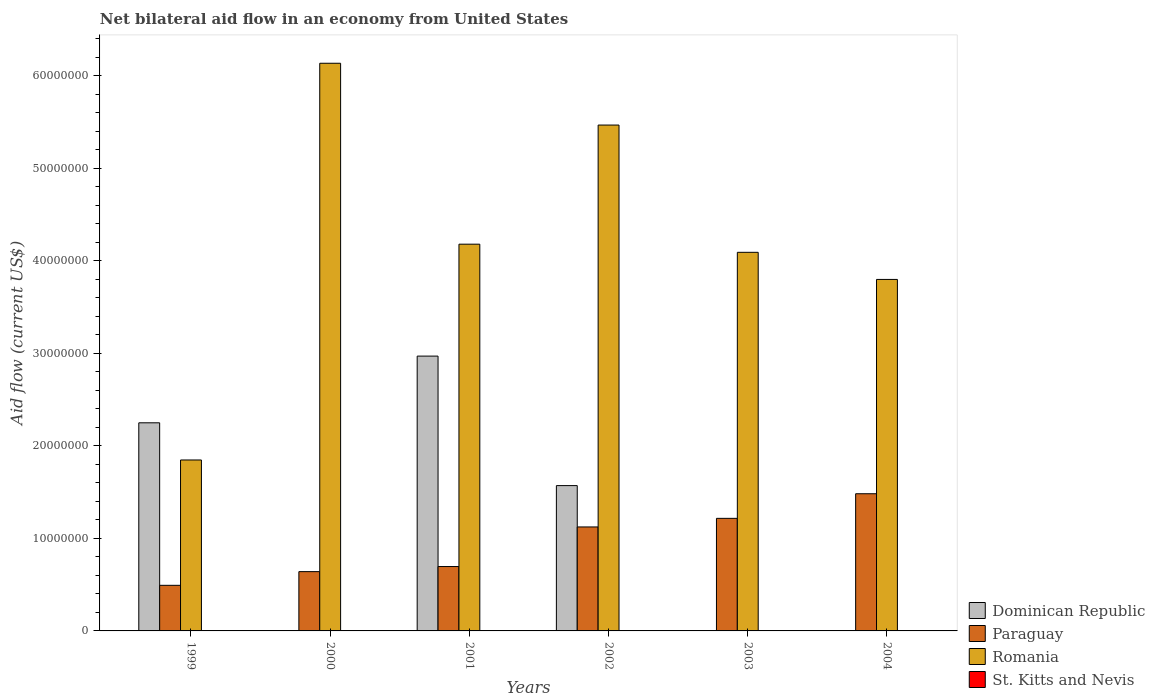How many different coloured bars are there?
Provide a short and direct response. 3. How many groups of bars are there?
Make the answer very short. 6. Are the number of bars per tick equal to the number of legend labels?
Ensure brevity in your answer.  No. What is the net bilateral aid flow in Romania in 2001?
Provide a short and direct response. 4.18e+07. Across all years, what is the maximum net bilateral aid flow in Paraguay?
Keep it short and to the point. 1.48e+07. Across all years, what is the minimum net bilateral aid flow in Romania?
Your answer should be very brief. 1.85e+07. In which year was the net bilateral aid flow in Romania maximum?
Your response must be concise. 2000. What is the total net bilateral aid flow in Dominican Republic in the graph?
Make the answer very short. 6.79e+07. What is the difference between the net bilateral aid flow in Romania in 1999 and that in 2001?
Your answer should be compact. -2.33e+07. What is the difference between the net bilateral aid flow in Paraguay in 2003 and the net bilateral aid flow in St. Kitts and Nevis in 2002?
Provide a short and direct response. 1.22e+07. What is the average net bilateral aid flow in Romania per year?
Your response must be concise. 4.25e+07. In the year 1999, what is the difference between the net bilateral aid flow in Paraguay and net bilateral aid flow in Romania?
Give a very brief answer. -1.36e+07. What is the ratio of the net bilateral aid flow in Paraguay in 2002 to that in 2003?
Make the answer very short. 0.92. Is the net bilateral aid flow in Romania in 2001 less than that in 2003?
Provide a succinct answer. No. Is the difference between the net bilateral aid flow in Paraguay in 2000 and 2003 greater than the difference between the net bilateral aid flow in Romania in 2000 and 2003?
Offer a terse response. No. What is the difference between the highest and the second highest net bilateral aid flow in Romania?
Give a very brief answer. 6.68e+06. What is the difference between the highest and the lowest net bilateral aid flow in Dominican Republic?
Keep it short and to the point. 2.97e+07. In how many years, is the net bilateral aid flow in Romania greater than the average net bilateral aid flow in Romania taken over all years?
Provide a short and direct response. 2. Is the sum of the net bilateral aid flow in Paraguay in 2001 and 2003 greater than the maximum net bilateral aid flow in Dominican Republic across all years?
Your response must be concise. No. Is it the case that in every year, the sum of the net bilateral aid flow in Dominican Republic and net bilateral aid flow in Paraguay is greater than the net bilateral aid flow in Romania?
Your answer should be compact. No. Are all the bars in the graph horizontal?
Provide a short and direct response. No. What is the difference between two consecutive major ticks on the Y-axis?
Make the answer very short. 1.00e+07. Are the values on the major ticks of Y-axis written in scientific E-notation?
Make the answer very short. No. Does the graph contain any zero values?
Give a very brief answer. Yes. Does the graph contain grids?
Ensure brevity in your answer.  No. How are the legend labels stacked?
Keep it short and to the point. Vertical. What is the title of the graph?
Your answer should be very brief. Net bilateral aid flow in an economy from United States. Does "Malawi" appear as one of the legend labels in the graph?
Make the answer very short. No. What is the label or title of the X-axis?
Ensure brevity in your answer.  Years. What is the Aid flow (current US$) in Dominican Republic in 1999?
Your answer should be compact. 2.25e+07. What is the Aid flow (current US$) of Paraguay in 1999?
Ensure brevity in your answer.  4.93e+06. What is the Aid flow (current US$) of Romania in 1999?
Give a very brief answer. 1.85e+07. What is the Aid flow (current US$) of St. Kitts and Nevis in 1999?
Provide a succinct answer. 0. What is the Aid flow (current US$) in Paraguay in 2000?
Keep it short and to the point. 6.41e+06. What is the Aid flow (current US$) of Romania in 2000?
Provide a succinct answer. 6.14e+07. What is the Aid flow (current US$) in St. Kitts and Nevis in 2000?
Ensure brevity in your answer.  0. What is the Aid flow (current US$) in Dominican Republic in 2001?
Offer a very short reply. 2.97e+07. What is the Aid flow (current US$) in Paraguay in 2001?
Ensure brevity in your answer.  6.96e+06. What is the Aid flow (current US$) of Romania in 2001?
Your answer should be very brief. 4.18e+07. What is the Aid flow (current US$) of Dominican Republic in 2002?
Keep it short and to the point. 1.57e+07. What is the Aid flow (current US$) of Paraguay in 2002?
Offer a very short reply. 1.12e+07. What is the Aid flow (current US$) in Romania in 2002?
Give a very brief answer. 5.47e+07. What is the Aid flow (current US$) of Paraguay in 2003?
Ensure brevity in your answer.  1.22e+07. What is the Aid flow (current US$) in Romania in 2003?
Offer a very short reply. 4.09e+07. What is the Aid flow (current US$) of Paraguay in 2004?
Offer a terse response. 1.48e+07. What is the Aid flow (current US$) in Romania in 2004?
Your answer should be compact. 3.80e+07. What is the Aid flow (current US$) of St. Kitts and Nevis in 2004?
Ensure brevity in your answer.  0. Across all years, what is the maximum Aid flow (current US$) of Dominican Republic?
Your answer should be very brief. 2.97e+07. Across all years, what is the maximum Aid flow (current US$) in Paraguay?
Give a very brief answer. 1.48e+07. Across all years, what is the maximum Aid flow (current US$) of Romania?
Give a very brief answer. 6.14e+07. Across all years, what is the minimum Aid flow (current US$) of Paraguay?
Make the answer very short. 4.93e+06. Across all years, what is the minimum Aid flow (current US$) in Romania?
Ensure brevity in your answer.  1.85e+07. What is the total Aid flow (current US$) in Dominican Republic in the graph?
Your response must be concise. 6.79e+07. What is the total Aid flow (current US$) in Paraguay in the graph?
Ensure brevity in your answer.  5.65e+07. What is the total Aid flow (current US$) of Romania in the graph?
Keep it short and to the point. 2.55e+08. What is the total Aid flow (current US$) in St. Kitts and Nevis in the graph?
Make the answer very short. 0. What is the difference between the Aid flow (current US$) of Paraguay in 1999 and that in 2000?
Offer a very short reply. -1.48e+06. What is the difference between the Aid flow (current US$) in Romania in 1999 and that in 2000?
Provide a succinct answer. -4.29e+07. What is the difference between the Aid flow (current US$) in Dominican Republic in 1999 and that in 2001?
Provide a short and direct response. -7.21e+06. What is the difference between the Aid flow (current US$) of Paraguay in 1999 and that in 2001?
Offer a very short reply. -2.03e+06. What is the difference between the Aid flow (current US$) in Romania in 1999 and that in 2001?
Give a very brief answer. -2.33e+07. What is the difference between the Aid flow (current US$) of Dominican Republic in 1999 and that in 2002?
Offer a very short reply. 6.79e+06. What is the difference between the Aid flow (current US$) of Paraguay in 1999 and that in 2002?
Make the answer very short. -6.31e+06. What is the difference between the Aid flow (current US$) of Romania in 1999 and that in 2002?
Make the answer very short. -3.62e+07. What is the difference between the Aid flow (current US$) of Paraguay in 1999 and that in 2003?
Make the answer very short. -7.24e+06. What is the difference between the Aid flow (current US$) in Romania in 1999 and that in 2003?
Provide a short and direct response. -2.24e+07. What is the difference between the Aid flow (current US$) of Paraguay in 1999 and that in 2004?
Offer a very short reply. -9.90e+06. What is the difference between the Aid flow (current US$) of Romania in 1999 and that in 2004?
Ensure brevity in your answer.  -1.95e+07. What is the difference between the Aid flow (current US$) of Paraguay in 2000 and that in 2001?
Provide a short and direct response. -5.50e+05. What is the difference between the Aid flow (current US$) in Romania in 2000 and that in 2001?
Keep it short and to the point. 1.96e+07. What is the difference between the Aid flow (current US$) in Paraguay in 2000 and that in 2002?
Make the answer very short. -4.83e+06. What is the difference between the Aid flow (current US$) of Romania in 2000 and that in 2002?
Provide a short and direct response. 6.68e+06. What is the difference between the Aid flow (current US$) of Paraguay in 2000 and that in 2003?
Provide a short and direct response. -5.76e+06. What is the difference between the Aid flow (current US$) of Romania in 2000 and that in 2003?
Give a very brief answer. 2.04e+07. What is the difference between the Aid flow (current US$) in Paraguay in 2000 and that in 2004?
Provide a short and direct response. -8.42e+06. What is the difference between the Aid flow (current US$) of Romania in 2000 and that in 2004?
Ensure brevity in your answer.  2.34e+07. What is the difference between the Aid flow (current US$) in Dominican Republic in 2001 and that in 2002?
Provide a succinct answer. 1.40e+07. What is the difference between the Aid flow (current US$) of Paraguay in 2001 and that in 2002?
Provide a short and direct response. -4.28e+06. What is the difference between the Aid flow (current US$) of Romania in 2001 and that in 2002?
Give a very brief answer. -1.29e+07. What is the difference between the Aid flow (current US$) in Paraguay in 2001 and that in 2003?
Your answer should be compact. -5.21e+06. What is the difference between the Aid flow (current US$) in Romania in 2001 and that in 2003?
Offer a very short reply. 8.80e+05. What is the difference between the Aid flow (current US$) in Paraguay in 2001 and that in 2004?
Give a very brief answer. -7.87e+06. What is the difference between the Aid flow (current US$) in Romania in 2001 and that in 2004?
Provide a succinct answer. 3.81e+06. What is the difference between the Aid flow (current US$) in Paraguay in 2002 and that in 2003?
Make the answer very short. -9.30e+05. What is the difference between the Aid flow (current US$) in Romania in 2002 and that in 2003?
Give a very brief answer. 1.38e+07. What is the difference between the Aid flow (current US$) in Paraguay in 2002 and that in 2004?
Your response must be concise. -3.59e+06. What is the difference between the Aid flow (current US$) in Romania in 2002 and that in 2004?
Give a very brief answer. 1.67e+07. What is the difference between the Aid flow (current US$) in Paraguay in 2003 and that in 2004?
Keep it short and to the point. -2.66e+06. What is the difference between the Aid flow (current US$) in Romania in 2003 and that in 2004?
Offer a very short reply. 2.93e+06. What is the difference between the Aid flow (current US$) in Dominican Republic in 1999 and the Aid flow (current US$) in Paraguay in 2000?
Your response must be concise. 1.61e+07. What is the difference between the Aid flow (current US$) of Dominican Republic in 1999 and the Aid flow (current US$) of Romania in 2000?
Give a very brief answer. -3.89e+07. What is the difference between the Aid flow (current US$) in Paraguay in 1999 and the Aid flow (current US$) in Romania in 2000?
Offer a very short reply. -5.64e+07. What is the difference between the Aid flow (current US$) of Dominican Republic in 1999 and the Aid flow (current US$) of Paraguay in 2001?
Offer a very short reply. 1.55e+07. What is the difference between the Aid flow (current US$) of Dominican Republic in 1999 and the Aid flow (current US$) of Romania in 2001?
Your response must be concise. -1.93e+07. What is the difference between the Aid flow (current US$) in Paraguay in 1999 and the Aid flow (current US$) in Romania in 2001?
Offer a terse response. -3.69e+07. What is the difference between the Aid flow (current US$) of Dominican Republic in 1999 and the Aid flow (current US$) of Paraguay in 2002?
Your answer should be compact. 1.13e+07. What is the difference between the Aid flow (current US$) in Dominican Republic in 1999 and the Aid flow (current US$) in Romania in 2002?
Offer a terse response. -3.22e+07. What is the difference between the Aid flow (current US$) of Paraguay in 1999 and the Aid flow (current US$) of Romania in 2002?
Ensure brevity in your answer.  -4.98e+07. What is the difference between the Aid flow (current US$) of Dominican Republic in 1999 and the Aid flow (current US$) of Paraguay in 2003?
Provide a short and direct response. 1.03e+07. What is the difference between the Aid flow (current US$) of Dominican Republic in 1999 and the Aid flow (current US$) of Romania in 2003?
Provide a short and direct response. -1.84e+07. What is the difference between the Aid flow (current US$) in Paraguay in 1999 and the Aid flow (current US$) in Romania in 2003?
Your response must be concise. -3.60e+07. What is the difference between the Aid flow (current US$) of Dominican Republic in 1999 and the Aid flow (current US$) of Paraguay in 2004?
Make the answer very short. 7.67e+06. What is the difference between the Aid flow (current US$) in Dominican Republic in 1999 and the Aid flow (current US$) in Romania in 2004?
Give a very brief answer. -1.55e+07. What is the difference between the Aid flow (current US$) in Paraguay in 1999 and the Aid flow (current US$) in Romania in 2004?
Your answer should be very brief. -3.31e+07. What is the difference between the Aid flow (current US$) in Paraguay in 2000 and the Aid flow (current US$) in Romania in 2001?
Offer a very short reply. -3.54e+07. What is the difference between the Aid flow (current US$) in Paraguay in 2000 and the Aid flow (current US$) in Romania in 2002?
Keep it short and to the point. -4.83e+07. What is the difference between the Aid flow (current US$) of Paraguay in 2000 and the Aid flow (current US$) of Romania in 2003?
Provide a succinct answer. -3.45e+07. What is the difference between the Aid flow (current US$) of Paraguay in 2000 and the Aid flow (current US$) of Romania in 2004?
Offer a very short reply. -3.16e+07. What is the difference between the Aid flow (current US$) in Dominican Republic in 2001 and the Aid flow (current US$) in Paraguay in 2002?
Provide a short and direct response. 1.85e+07. What is the difference between the Aid flow (current US$) in Dominican Republic in 2001 and the Aid flow (current US$) in Romania in 2002?
Provide a short and direct response. -2.50e+07. What is the difference between the Aid flow (current US$) of Paraguay in 2001 and the Aid flow (current US$) of Romania in 2002?
Your answer should be compact. -4.77e+07. What is the difference between the Aid flow (current US$) in Dominican Republic in 2001 and the Aid flow (current US$) in Paraguay in 2003?
Keep it short and to the point. 1.75e+07. What is the difference between the Aid flow (current US$) in Dominican Republic in 2001 and the Aid flow (current US$) in Romania in 2003?
Offer a terse response. -1.12e+07. What is the difference between the Aid flow (current US$) in Paraguay in 2001 and the Aid flow (current US$) in Romania in 2003?
Ensure brevity in your answer.  -3.40e+07. What is the difference between the Aid flow (current US$) in Dominican Republic in 2001 and the Aid flow (current US$) in Paraguay in 2004?
Your answer should be very brief. 1.49e+07. What is the difference between the Aid flow (current US$) in Dominican Republic in 2001 and the Aid flow (current US$) in Romania in 2004?
Provide a succinct answer. -8.29e+06. What is the difference between the Aid flow (current US$) of Paraguay in 2001 and the Aid flow (current US$) of Romania in 2004?
Provide a succinct answer. -3.10e+07. What is the difference between the Aid flow (current US$) in Dominican Republic in 2002 and the Aid flow (current US$) in Paraguay in 2003?
Provide a short and direct response. 3.54e+06. What is the difference between the Aid flow (current US$) of Dominican Republic in 2002 and the Aid flow (current US$) of Romania in 2003?
Provide a short and direct response. -2.52e+07. What is the difference between the Aid flow (current US$) in Paraguay in 2002 and the Aid flow (current US$) in Romania in 2003?
Make the answer very short. -2.97e+07. What is the difference between the Aid flow (current US$) of Dominican Republic in 2002 and the Aid flow (current US$) of Paraguay in 2004?
Provide a short and direct response. 8.80e+05. What is the difference between the Aid flow (current US$) of Dominican Republic in 2002 and the Aid flow (current US$) of Romania in 2004?
Offer a very short reply. -2.23e+07. What is the difference between the Aid flow (current US$) in Paraguay in 2002 and the Aid flow (current US$) in Romania in 2004?
Keep it short and to the point. -2.68e+07. What is the difference between the Aid flow (current US$) of Paraguay in 2003 and the Aid flow (current US$) of Romania in 2004?
Your response must be concise. -2.58e+07. What is the average Aid flow (current US$) in Dominican Republic per year?
Offer a terse response. 1.13e+07. What is the average Aid flow (current US$) in Paraguay per year?
Your response must be concise. 9.42e+06. What is the average Aid flow (current US$) in Romania per year?
Ensure brevity in your answer.  4.25e+07. In the year 1999, what is the difference between the Aid flow (current US$) of Dominican Republic and Aid flow (current US$) of Paraguay?
Make the answer very short. 1.76e+07. In the year 1999, what is the difference between the Aid flow (current US$) in Dominican Republic and Aid flow (current US$) in Romania?
Keep it short and to the point. 4.02e+06. In the year 1999, what is the difference between the Aid flow (current US$) of Paraguay and Aid flow (current US$) of Romania?
Make the answer very short. -1.36e+07. In the year 2000, what is the difference between the Aid flow (current US$) of Paraguay and Aid flow (current US$) of Romania?
Keep it short and to the point. -5.50e+07. In the year 2001, what is the difference between the Aid flow (current US$) in Dominican Republic and Aid flow (current US$) in Paraguay?
Make the answer very short. 2.28e+07. In the year 2001, what is the difference between the Aid flow (current US$) of Dominican Republic and Aid flow (current US$) of Romania?
Your response must be concise. -1.21e+07. In the year 2001, what is the difference between the Aid flow (current US$) in Paraguay and Aid flow (current US$) in Romania?
Make the answer very short. -3.48e+07. In the year 2002, what is the difference between the Aid flow (current US$) in Dominican Republic and Aid flow (current US$) in Paraguay?
Offer a very short reply. 4.47e+06. In the year 2002, what is the difference between the Aid flow (current US$) in Dominican Republic and Aid flow (current US$) in Romania?
Your answer should be compact. -3.90e+07. In the year 2002, what is the difference between the Aid flow (current US$) of Paraguay and Aid flow (current US$) of Romania?
Your answer should be compact. -4.34e+07. In the year 2003, what is the difference between the Aid flow (current US$) in Paraguay and Aid flow (current US$) in Romania?
Offer a terse response. -2.88e+07. In the year 2004, what is the difference between the Aid flow (current US$) in Paraguay and Aid flow (current US$) in Romania?
Your response must be concise. -2.32e+07. What is the ratio of the Aid flow (current US$) in Paraguay in 1999 to that in 2000?
Provide a succinct answer. 0.77. What is the ratio of the Aid flow (current US$) of Romania in 1999 to that in 2000?
Your answer should be very brief. 0.3. What is the ratio of the Aid flow (current US$) in Dominican Republic in 1999 to that in 2001?
Offer a very short reply. 0.76. What is the ratio of the Aid flow (current US$) of Paraguay in 1999 to that in 2001?
Make the answer very short. 0.71. What is the ratio of the Aid flow (current US$) in Romania in 1999 to that in 2001?
Your response must be concise. 0.44. What is the ratio of the Aid flow (current US$) in Dominican Republic in 1999 to that in 2002?
Your response must be concise. 1.43. What is the ratio of the Aid flow (current US$) in Paraguay in 1999 to that in 2002?
Make the answer very short. 0.44. What is the ratio of the Aid flow (current US$) in Romania in 1999 to that in 2002?
Give a very brief answer. 0.34. What is the ratio of the Aid flow (current US$) in Paraguay in 1999 to that in 2003?
Offer a very short reply. 0.41. What is the ratio of the Aid flow (current US$) in Romania in 1999 to that in 2003?
Your response must be concise. 0.45. What is the ratio of the Aid flow (current US$) of Paraguay in 1999 to that in 2004?
Give a very brief answer. 0.33. What is the ratio of the Aid flow (current US$) in Romania in 1999 to that in 2004?
Keep it short and to the point. 0.49. What is the ratio of the Aid flow (current US$) in Paraguay in 2000 to that in 2001?
Keep it short and to the point. 0.92. What is the ratio of the Aid flow (current US$) of Romania in 2000 to that in 2001?
Offer a terse response. 1.47. What is the ratio of the Aid flow (current US$) in Paraguay in 2000 to that in 2002?
Your response must be concise. 0.57. What is the ratio of the Aid flow (current US$) in Romania in 2000 to that in 2002?
Make the answer very short. 1.12. What is the ratio of the Aid flow (current US$) in Paraguay in 2000 to that in 2003?
Ensure brevity in your answer.  0.53. What is the ratio of the Aid flow (current US$) in Romania in 2000 to that in 2003?
Your answer should be very brief. 1.5. What is the ratio of the Aid flow (current US$) of Paraguay in 2000 to that in 2004?
Provide a short and direct response. 0.43. What is the ratio of the Aid flow (current US$) of Romania in 2000 to that in 2004?
Give a very brief answer. 1.61. What is the ratio of the Aid flow (current US$) in Dominican Republic in 2001 to that in 2002?
Your answer should be compact. 1.89. What is the ratio of the Aid flow (current US$) in Paraguay in 2001 to that in 2002?
Offer a terse response. 0.62. What is the ratio of the Aid flow (current US$) in Romania in 2001 to that in 2002?
Provide a short and direct response. 0.76. What is the ratio of the Aid flow (current US$) in Paraguay in 2001 to that in 2003?
Offer a terse response. 0.57. What is the ratio of the Aid flow (current US$) of Romania in 2001 to that in 2003?
Ensure brevity in your answer.  1.02. What is the ratio of the Aid flow (current US$) in Paraguay in 2001 to that in 2004?
Give a very brief answer. 0.47. What is the ratio of the Aid flow (current US$) in Romania in 2001 to that in 2004?
Offer a very short reply. 1.1. What is the ratio of the Aid flow (current US$) in Paraguay in 2002 to that in 2003?
Give a very brief answer. 0.92. What is the ratio of the Aid flow (current US$) of Romania in 2002 to that in 2003?
Give a very brief answer. 1.34. What is the ratio of the Aid flow (current US$) of Paraguay in 2002 to that in 2004?
Your answer should be compact. 0.76. What is the ratio of the Aid flow (current US$) in Romania in 2002 to that in 2004?
Your answer should be compact. 1.44. What is the ratio of the Aid flow (current US$) of Paraguay in 2003 to that in 2004?
Your answer should be compact. 0.82. What is the ratio of the Aid flow (current US$) of Romania in 2003 to that in 2004?
Make the answer very short. 1.08. What is the difference between the highest and the second highest Aid flow (current US$) in Dominican Republic?
Your answer should be very brief. 7.21e+06. What is the difference between the highest and the second highest Aid flow (current US$) of Paraguay?
Provide a succinct answer. 2.66e+06. What is the difference between the highest and the second highest Aid flow (current US$) in Romania?
Your response must be concise. 6.68e+06. What is the difference between the highest and the lowest Aid flow (current US$) in Dominican Republic?
Offer a terse response. 2.97e+07. What is the difference between the highest and the lowest Aid flow (current US$) of Paraguay?
Provide a succinct answer. 9.90e+06. What is the difference between the highest and the lowest Aid flow (current US$) in Romania?
Your answer should be compact. 4.29e+07. 